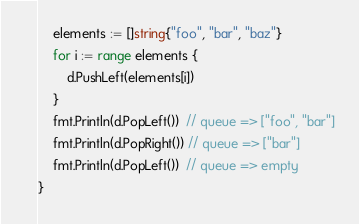<code> <loc_0><loc_0><loc_500><loc_500><_Go_>	elements := []string{"foo", "bar", "baz"}
	for i := range elements {
		d.PushLeft(elements[i])
	}
	fmt.Println(d.PopLeft())  // queue => ["foo", "bar"]
	fmt.Println(d.PopRight()) // queue => ["bar"]
	fmt.Println(d.PopLeft())  // queue => empty
}
</code> 